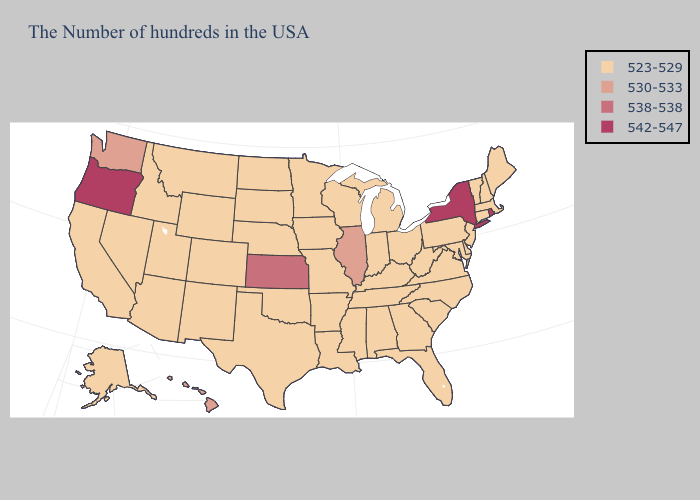Which states have the lowest value in the USA?
Keep it brief. Maine, Massachusetts, New Hampshire, Vermont, Connecticut, New Jersey, Delaware, Maryland, Pennsylvania, Virginia, North Carolina, South Carolina, West Virginia, Ohio, Florida, Georgia, Michigan, Kentucky, Indiana, Alabama, Tennessee, Wisconsin, Mississippi, Louisiana, Missouri, Arkansas, Minnesota, Iowa, Nebraska, Oklahoma, Texas, South Dakota, North Dakota, Wyoming, Colorado, New Mexico, Utah, Montana, Arizona, Idaho, Nevada, California, Alaska. Which states have the lowest value in the USA?
Keep it brief. Maine, Massachusetts, New Hampshire, Vermont, Connecticut, New Jersey, Delaware, Maryland, Pennsylvania, Virginia, North Carolina, South Carolina, West Virginia, Ohio, Florida, Georgia, Michigan, Kentucky, Indiana, Alabama, Tennessee, Wisconsin, Mississippi, Louisiana, Missouri, Arkansas, Minnesota, Iowa, Nebraska, Oklahoma, Texas, South Dakota, North Dakota, Wyoming, Colorado, New Mexico, Utah, Montana, Arizona, Idaho, Nevada, California, Alaska. Name the states that have a value in the range 542-547?
Short answer required. Rhode Island, New York, Oregon. What is the highest value in the USA?
Quick response, please. 542-547. Does Oregon have the highest value in the USA?
Keep it brief. Yes. Does Oklahoma have a lower value than Nevada?
Be succinct. No. What is the highest value in the MidWest ?
Concise answer only. 538-538. Does the map have missing data?
Write a very short answer. No. Does New York have the lowest value in the Northeast?
Short answer required. No. Which states have the lowest value in the USA?
Write a very short answer. Maine, Massachusetts, New Hampshire, Vermont, Connecticut, New Jersey, Delaware, Maryland, Pennsylvania, Virginia, North Carolina, South Carolina, West Virginia, Ohio, Florida, Georgia, Michigan, Kentucky, Indiana, Alabama, Tennessee, Wisconsin, Mississippi, Louisiana, Missouri, Arkansas, Minnesota, Iowa, Nebraska, Oklahoma, Texas, South Dakota, North Dakota, Wyoming, Colorado, New Mexico, Utah, Montana, Arizona, Idaho, Nevada, California, Alaska. How many symbols are there in the legend?
Be succinct. 4. Among the states that border Texas , which have the highest value?
Quick response, please. Louisiana, Arkansas, Oklahoma, New Mexico. Name the states that have a value in the range 542-547?
Be succinct. Rhode Island, New York, Oregon. What is the value of Delaware?
Quick response, please. 523-529. 